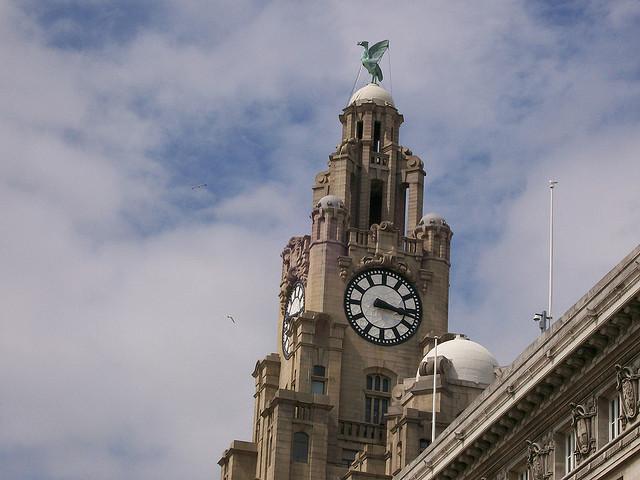Why are there ropes on the statue?
Select the correct answer and articulate reasoning with the following format: 'Answer: answer
Rationale: rationale.'
Options: Moving it, theft, stability, design. Answer: stability.
Rationale: The ropes give stability. 